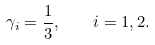Convert formula to latex. <formula><loc_0><loc_0><loc_500><loc_500>\gamma _ { i } = \frac { 1 } { 3 } , \quad i = 1 , 2 .</formula> 